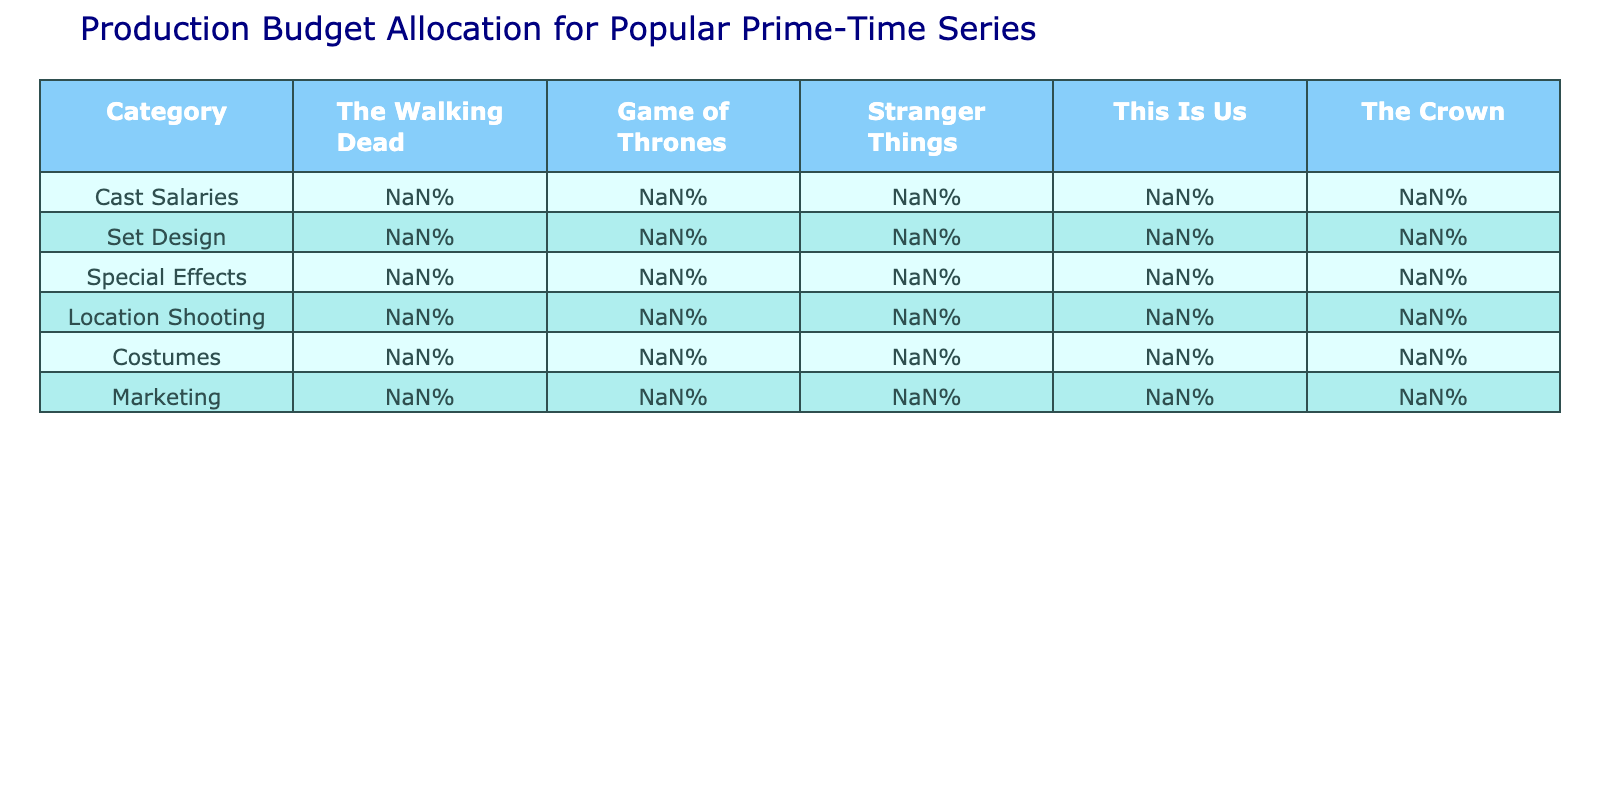What is the largest percentage allocated to cast salaries among the series? The table shows the percentage allocations for cast salaries: The Walking Dead (35%), Game of Thrones (40%), Stranger Things (30%), This Is Us (45%), and The Crown (38%). The highest percentage is from This Is Us at 45%.
Answer: 45% Which series allocates the least percentage to location shooting? Location shooting percentages are as follows: The Walking Dead (12%), Game of Thrones (10%), Stranger Things (8%), This Is Us (15%), and The Crown (15%). The lowest allocation is for Stranger Things at 8%.
Answer: 8% Calculate the total percentage allocated to special effects across all series. The special effects percentages are: The Walking Dead (20%), Game of Thrones (18%), Stranger Things (25%), This Is Us (5%), and The Crown (12%). Summing these yields 20 + 18 + 25 + 5 + 12 = 80%.
Answer: 80% Is the percentage allocated to marketing higher for This Is Us than for Game of Thrones? Marketing percentages are This Is Us (20%) and Game of Thrones (5%). Since 20% is greater than 5%, the statement is true.
Answer: Yes What is the average allocation percentage for set design across all series? To find the average, we add the set design percentages: 15% + 20% + 18% + 10% + 22% = 85%. There are 5 series, so the average is 85% / 5 = 17%.
Answer: 17% Which series has the highest allocation for special effects, and what is that percentage? The percentage allocations for special effects are: The Walking Dead (20%), Game of Thrones (18%), Stranger Things (25%), This Is Us (5%), and The Crown (12%). Stranger Things has the highest allocation at 25%.
Answer: 25% Is there a series that allocates no percentage to cast salaries? From the table, all series have an allocation for cast salaries: The Walking Dead (35%), Game of Thrones (40%), Stranger Things (30%), This Is Us (45%), and The Crown (38%). Therefore, the answer is no.
Answer: No What is the difference in percentage between the highest and lowest allocation for costumes? The percentages for costumes are: The Walking Dead (8%), Game of Thrones (7%), Stranger Things (10%), This Is Us (5%), and The Crown (8%). The highest is 10% (Stranger Things) and the lowest is 5% (This Is Us). The difference is 10% - 5% = 5%.
Answer: 5% What series allocates the most to set design, and what percentage is that? The set design allocations are: The Walking Dead (15%), Game of Thrones (20%), Stranger Things (18%), This Is Us (10%), and The Crown (22%). The Crown allocates the most at 22%.
Answer: 22% If we combine the percentages of cast salaries and special effects for Game of Thrones, what do we get? Game of Thrones has a cast salary allocation of 40% and a special effects allocation of 18%. Summing these gives 40% + 18% = 58%.
Answer: 58% 